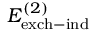<formula> <loc_0><loc_0><loc_500><loc_500>E _ { e x c h - i n d } ^ { ( 2 ) }</formula> 